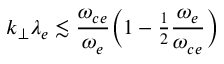Convert formula to latex. <formula><loc_0><loc_0><loc_500><loc_500>k _ { \perp } \lambda _ { e } \lesssim \frac { \omega _ { c e } } { \omega _ { e } } \left ( 1 - { \frac { 1 } { 2 } } \frac { \omega _ { e } } { \omega _ { c e } } \right )</formula> 